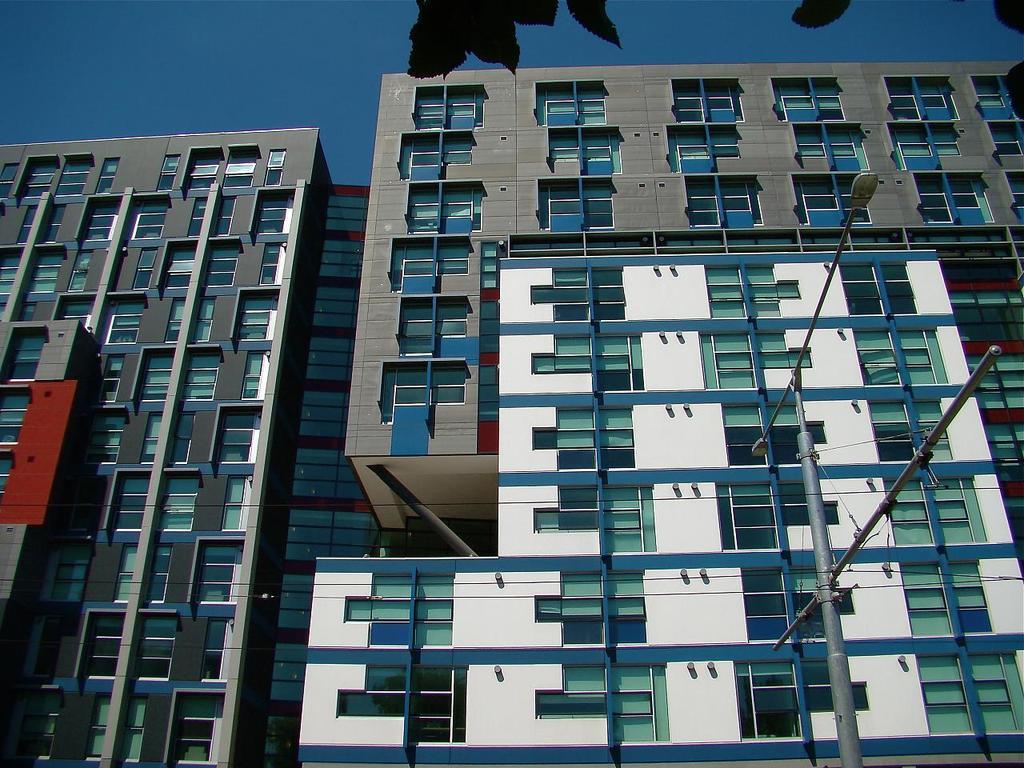How would you summarize this image in a sentence or two? In this image we can see buildings, street pole, street lights, leaves and sky. 